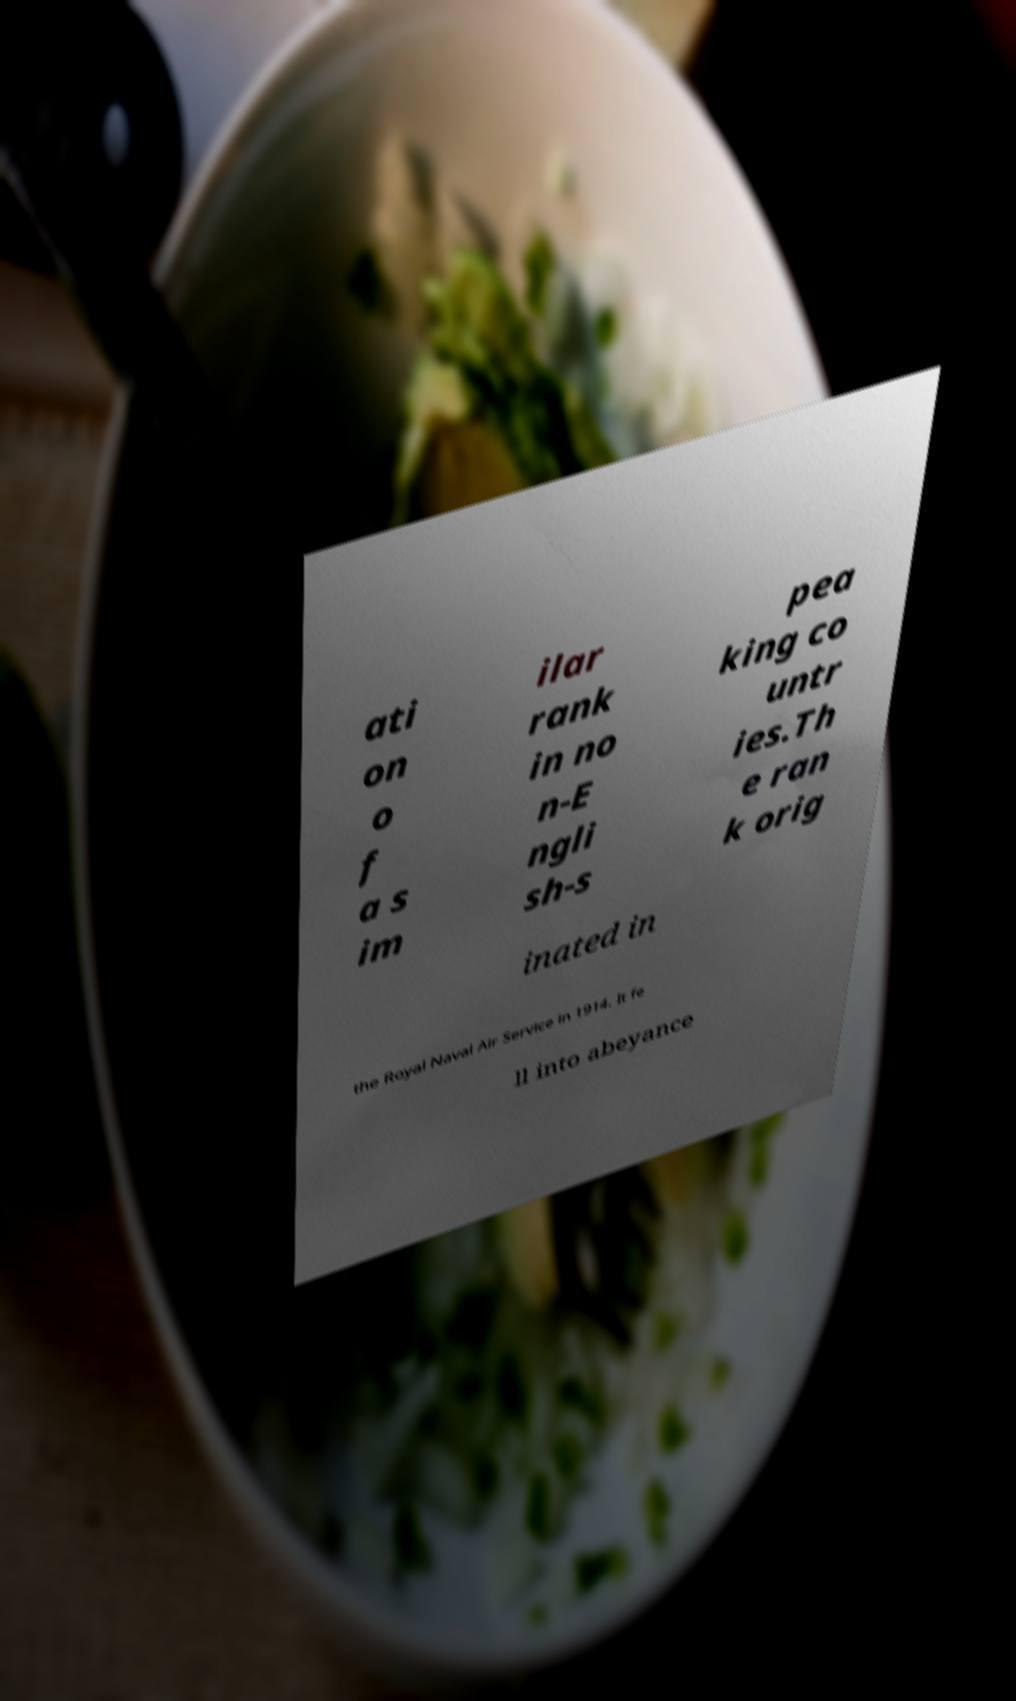Could you assist in decoding the text presented in this image and type it out clearly? ati on o f a s im ilar rank in no n-E ngli sh-s pea king co untr ies.Th e ran k orig inated in the Royal Naval Air Service in 1914. It fe ll into abeyance 